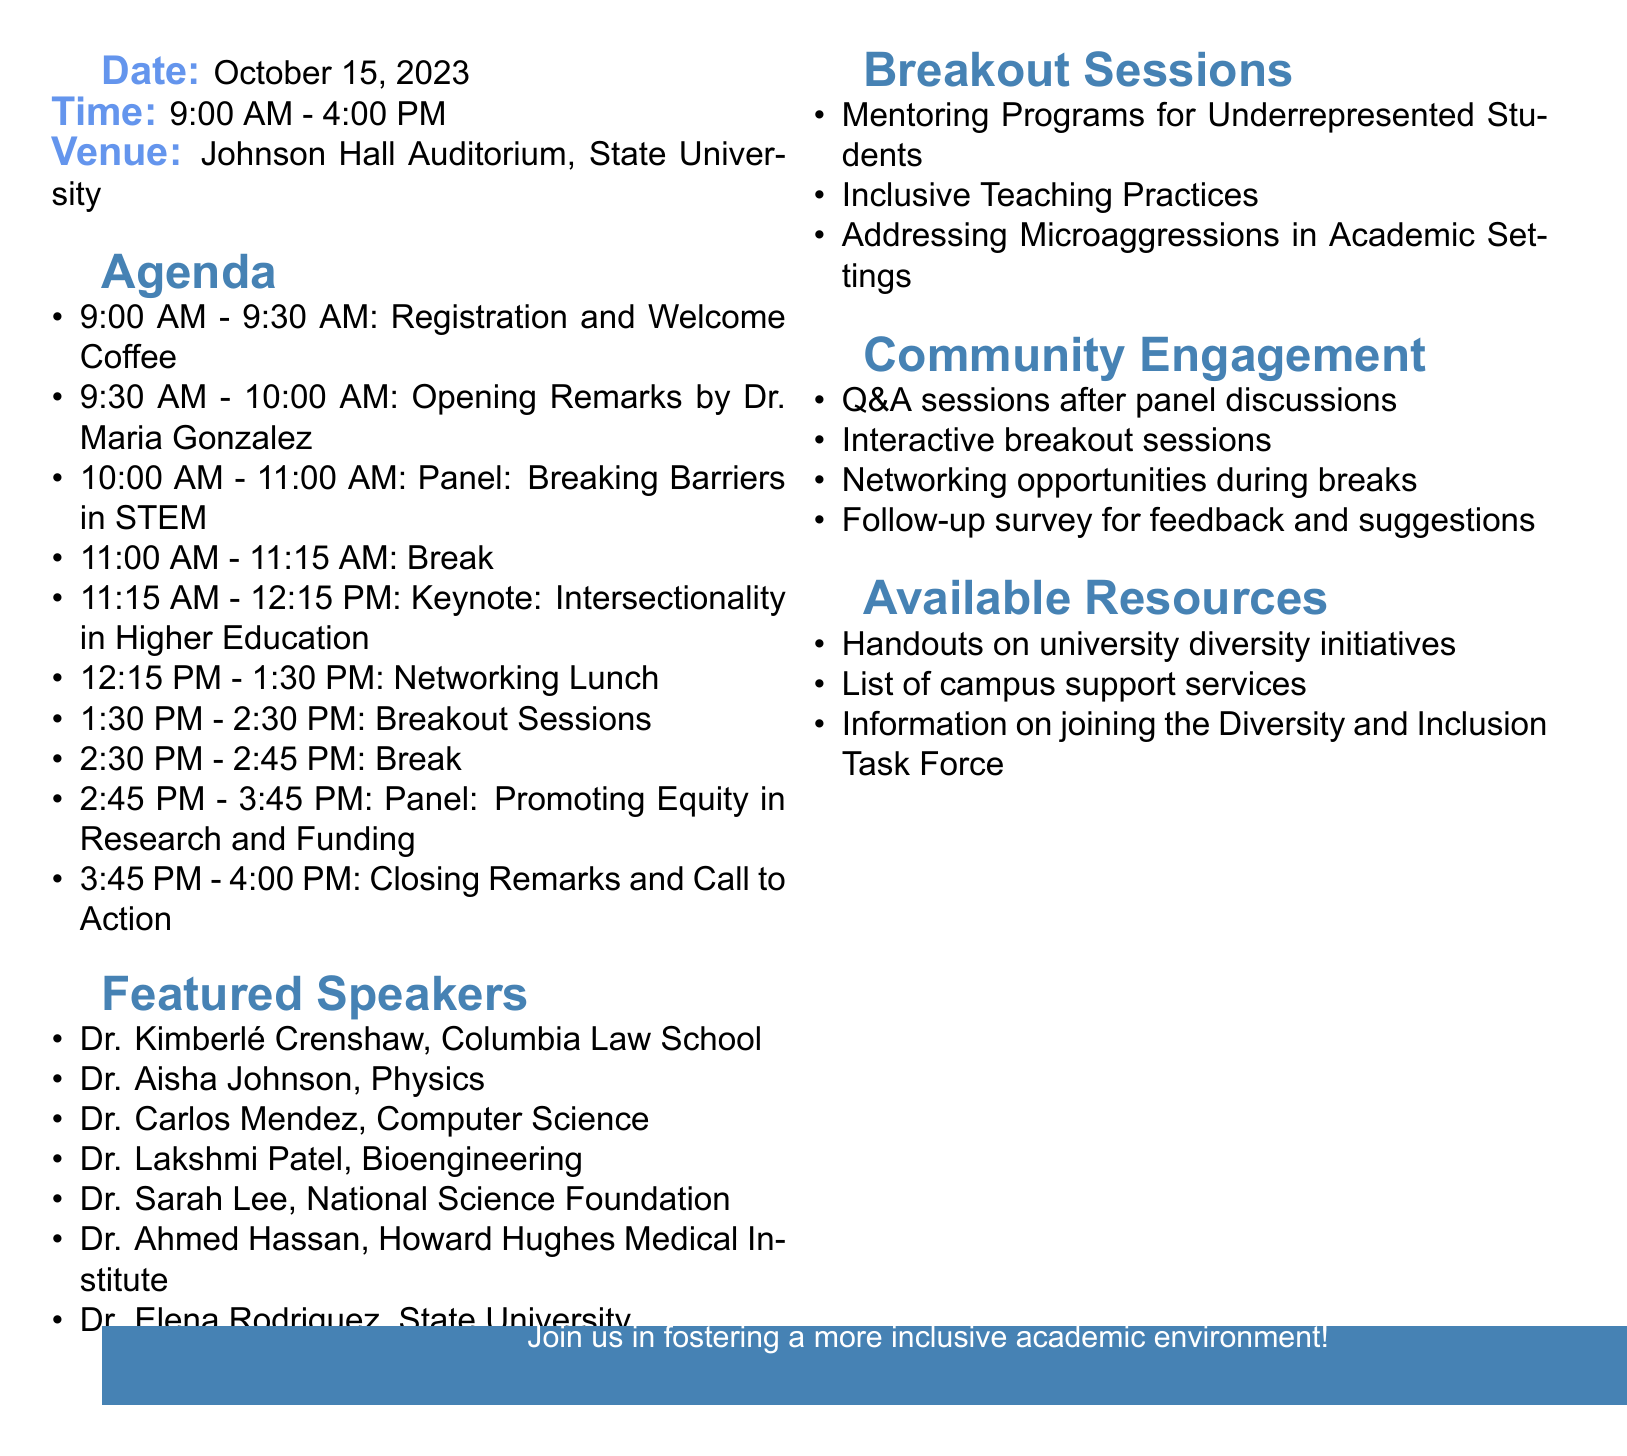what is the event title? The event title is specified at the beginning of the document and describes the theme of the roundtable discussion.
Answer: Diversity and Inclusion in Academia: Voices from Underrepresented Groups when does the event take place? The date of the event is provided clearly in the document, specifying when it will occur.
Answer: October 15, 2023 who is the keynote speaker? The document lists the keynote address along with the speaker's name, making it easy to identify.
Answer: Dr. Kimberlé Crenshaw what time does the registration start? The agenda specifies the time for registration as the first activity of the day.
Answer: 9:00 AM how long is the networking lunch? The duration of the lunch is explicitly mentioned in the agenda, allowing for quick reference.
Answer: 1 hour 15 minutes which panel discusses equity in research? The document includes specific panels and their focus areas, helping to identify relevant discussions.
Answer: Promoting Equity in Research and Funding who is moderating the panel on STEM? The document lists the moderator's name alongside the specific panel it pertains to, providing clarity on roles.
Answer: Dr. James Chen what is included in community engagement opportunities? The document outlines different ways for the community to engage during the event, highlighting their participation options.
Answer: Q&A sessions after each panel discussion what will attendees receive related to diversity initiatives? The resources listed in the document detail what attendees can expect to take away from the event.
Answer: Handouts on university diversity initiatives 